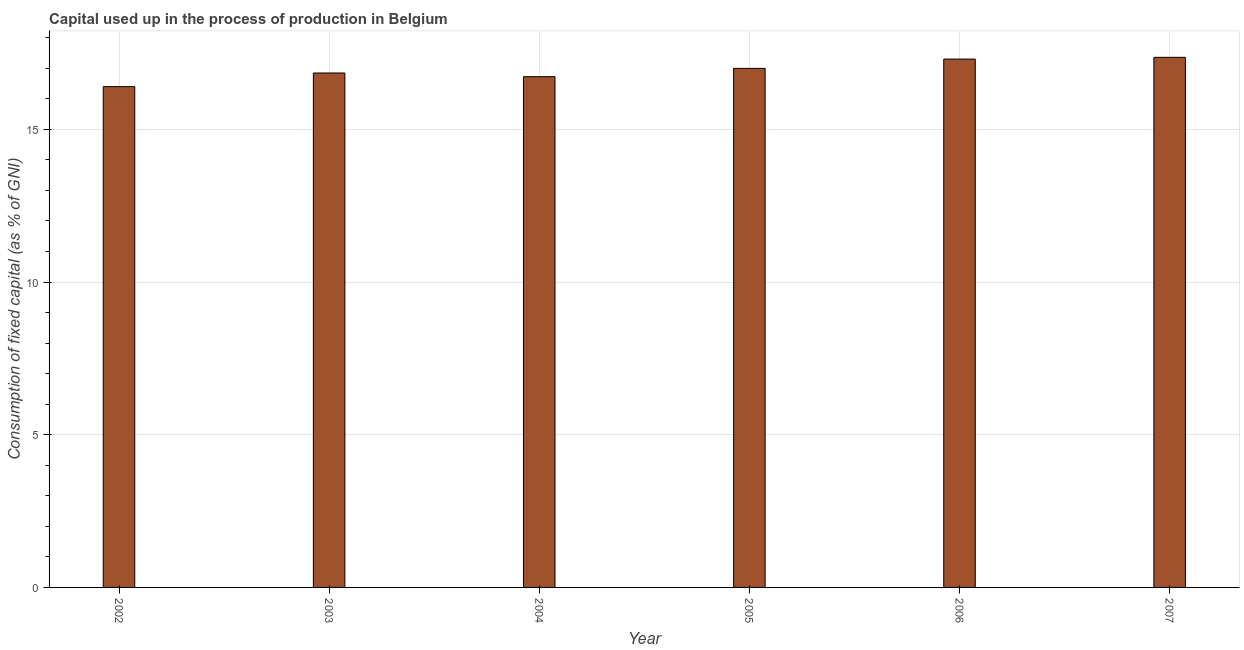Does the graph contain any zero values?
Ensure brevity in your answer.  No. What is the title of the graph?
Provide a short and direct response. Capital used up in the process of production in Belgium. What is the label or title of the Y-axis?
Your answer should be compact. Consumption of fixed capital (as % of GNI). What is the consumption of fixed capital in 2007?
Provide a succinct answer. 17.36. Across all years, what is the maximum consumption of fixed capital?
Your answer should be compact. 17.36. Across all years, what is the minimum consumption of fixed capital?
Give a very brief answer. 16.4. What is the sum of the consumption of fixed capital?
Keep it short and to the point. 101.62. What is the difference between the consumption of fixed capital in 2002 and 2006?
Give a very brief answer. -0.9. What is the average consumption of fixed capital per year?
Offer a very short reply. 16.94. What is the median consumption of fixed capital?
Ensure brevity in your answer.  16.92. Do a majority of the years between 2003 and 2004 (inclusive) have consumption of fixed capital greater than 9 %?
Ensure brevity in your answer.  Yes. What is the ratio of the consumption of fixed capital in 2003 to that in 2005?
Provide a succinct answer. 0.99. Is the consumption of fixed capital in 2005 less than that in 2006?
Your response must be concise. Yes. Is the difference between the consumption of fixed capital in 2003 and 2006 greater than the difference between any two years?
Ensure brevity in your answer.  No. What is the difference between the highest and the second highest consumption of fixed capital?
Provide a short and direct response. 0.06. Is the sum of the consumption of fixed capital in 2003 and 2005 greater than the maximum consumption of fixed capital across all years?
Offer a terse response. Yes. What is the difference between the highest and the lowest consumption of fixed capital?
Offer a very short reply. 0.96. Are all the bars in the graph horizontal?
Give a very brief answer. No. What is the Consumption of fixed capital (as % of GNI) of 2002?
Your answer should be very brief. 16.4. What is the Consumption of fixed capital (as % of GNI) in 2003?
Your answer should be very brief. 16.85. What is the Consumption of fixed capital (as % of GNI) in 2004?
Make the answer very short. 16.72. What is the Consumption of fixed capital (as % of GNI) of 2005?
Offer a terse response. 17. What is the Consumption of fixed capital (as % of GNI) of 2006?
Your answer should be very brief. 17.3. What is the Consumption of fixed capital (as % of GNI) of 2007?
Make the answer very short. 17.36. What is the difference between the Consumption of fixed capital (as % of GNI) in 2002 and 2003?
Provide a succinct answer. -0.45. What is the difference between the Consumption of fixed capital (as % of GNI) in 2002 and 2004?
Your response must be concise. -0.33. What is the difference between the Consumption of fixed capital (as % of GNI) in 2002 and 2005?
Offer a terse response. -0.6. What is the difference between the Consumption of fixed capital (as % of GNI) in 2002 and 2006?
Keep it short and to the point. -0.9. What is the difference between the Consumption of fixed capital (as % of GNI) in 2002 and 2007?
Provide a short and direct response. -0.96. What is the difference between the Consumption of fixed capital (as % of GNI) in 2003 and 2004?
Give a very brief answer. 0.12. What is the difference between the Consumption of fixed capital (as % of GNI) in 2003 and 2005?
Provide a succinct answer. -0.15. What is the difference between the Consumption of fixed capital (as % of GNI) in 2003 and 2006?
Your answer should be very brief. -0.46. What is the difference between the Consumption of fixed capital (as % of GNI) in 2003 and 2007?
Make the answer very short. -0.51. What is the difference between the Consumption of fixed capital (as % of GNI) in 2004 and 2005?
Offer a terse response. -0.27. What is the difference between the Consumption of fixed capital (as % of GNI) in 2004 and 2006?
Give a very brief answer. -0.58. What is the difference between the Consumption of fixed capital (as % of GNI) in 2004 and 2007?
Keep it short and to the point. -0.63. What is the difference between the Consumption of fixed capital (as % of GNI) in 2005 and 2006?
Provide a succinct answer. -0.3. What is the difference between the Consumption of fixed capital (as % of GNI) in 2005 and 2007?
Offer a terse response. -0.36. What is the difference between the Consumption of fixed capital (as % of GNI) in 2006 and 2007?
Offer a terse response. -0.06. What is the ratio of the Consumption of fixed capital (as % of GNI) in 2002 to that in 2005?
Ensure brevity in your answer.  0.96. What is the ratio of the Consumption of fixed capital (as % of GNI) in 2002 to that in 2006?
Provide a succinct answer. 0.95. What is the ratio of the Consumption of fixed capital (as % of GNI) in 2002 to that in 2007?
Give a very brief answer. 0.94. What is the ratio of the Consumption of fixed capital (as % of GNI) in 2003 to that in 2005?
Make the answer very short. 0.99. What is the ratio of the Consumption of fixed capital (as % of GNI) in 2005 to that in 2006?
Ensure brevity in your answer.  0.98. 